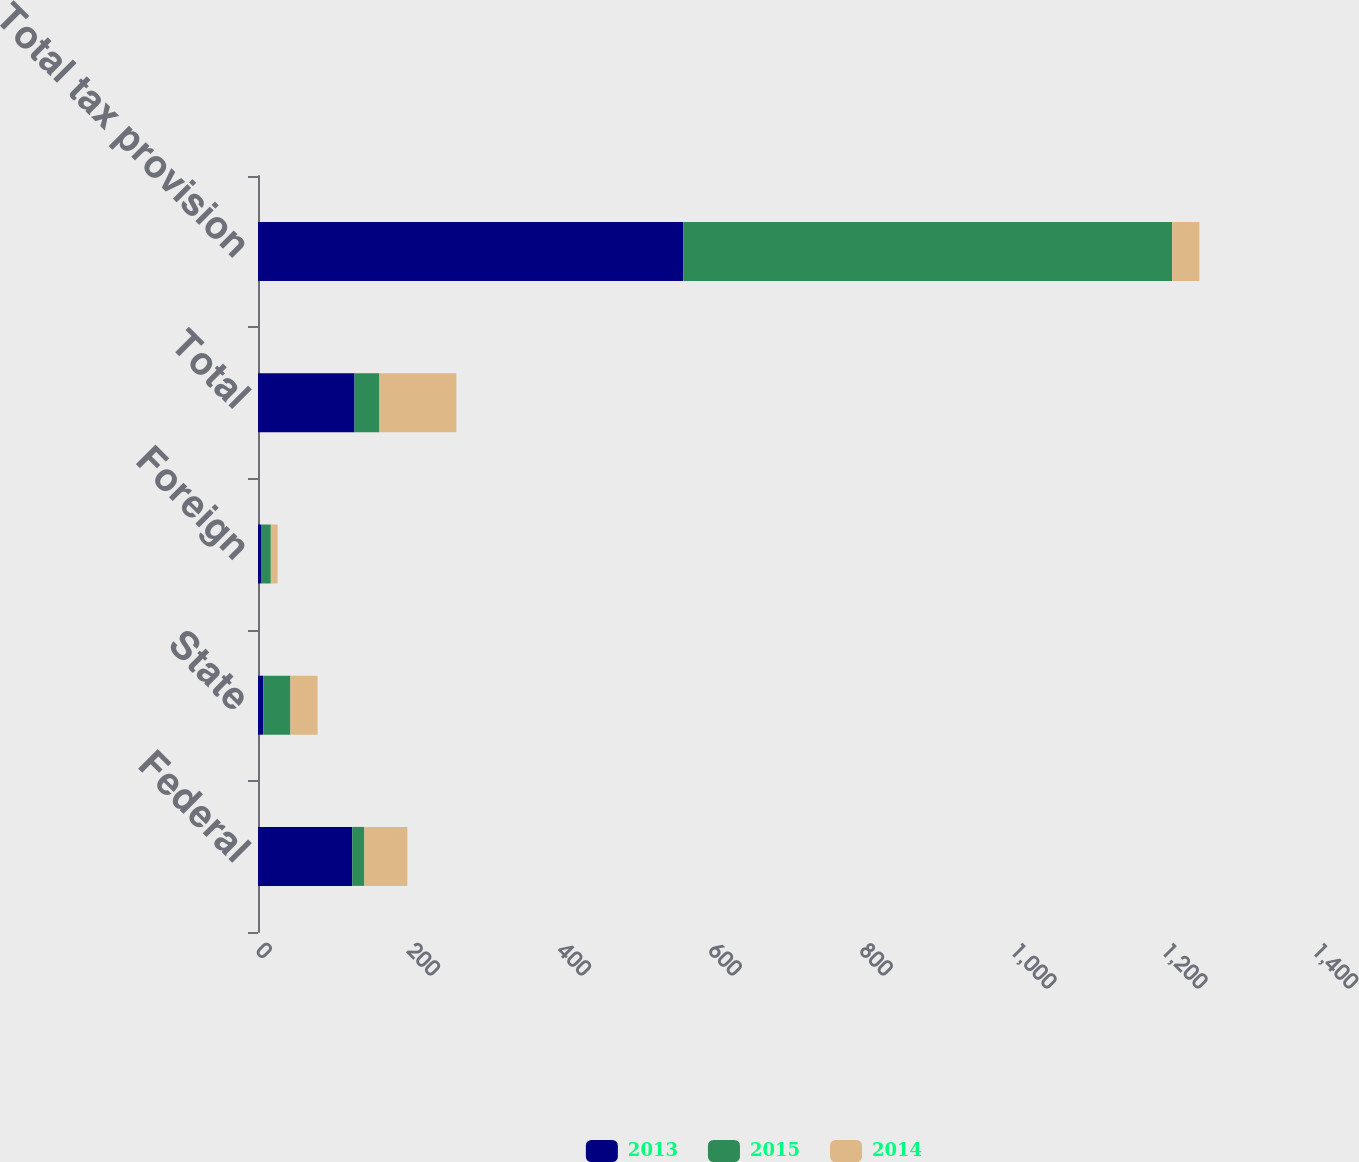<chart> <loc_0><loc_0><loc_500><loc_500><stacked_bar_chart><ecel><fcel>Federal<fcel>State<fcel>Foreign<fcel>Total<fcel>Total tax provision<nl><fcel>2013<fcel>125<fcel>7<fcel>4<fcel>128<fcel>564<nl><fcel>2015<fcel>16<fcel>36<fcel>13<fcel>33<fcel>648<nl><fcel>2014<fcel>57<fcel>36<fcel>9<fcel>102<fcel>36<nl></chart> 